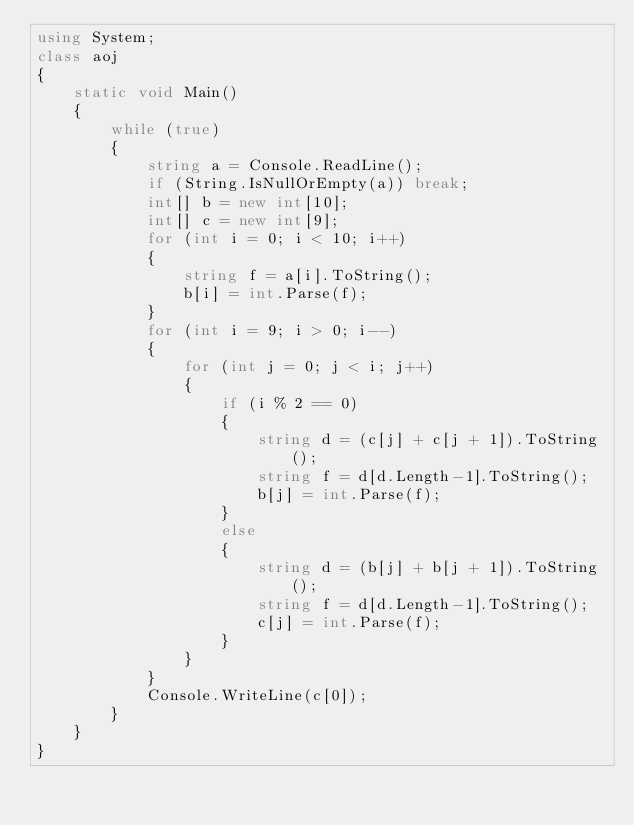<code> <loc_0><loc_0><loc_500><loc_500><_C#_>using System;
class aoj
{
    static void Main()
    {
        while (true)
        {
            string a = Console.ReadLine();
            if (String.IsNullOrEmpty(a)) break;
            int[] b = new int[10];
            int[] c = new int[9];
            for (int i = 0; i < 10; i++)
            {
                string f = a[i].ToString();
                b[i] = int.Parse(f);
            }
            for (int i = 9; i > 0; i--)
            {
                for (int j = 0; j < i; j++)
                {
                    if (i % 2 == 0)
                    {
                        string d = (c[j] + c[j + 1]).ToString();
                        string f = d[d.Length-1].ToString();
                        b[j] = int.Parse(f);
                    }
                    else
                    {
                        string d = (b[j] + b[j + 1]).ToString();
                        string f = d[d.Length-1].ToString();
                        c[j] = int.Parse(f);
                    }
                }
            }
            Console.WriteLine(c[0]);
        }
    }
}</code> 